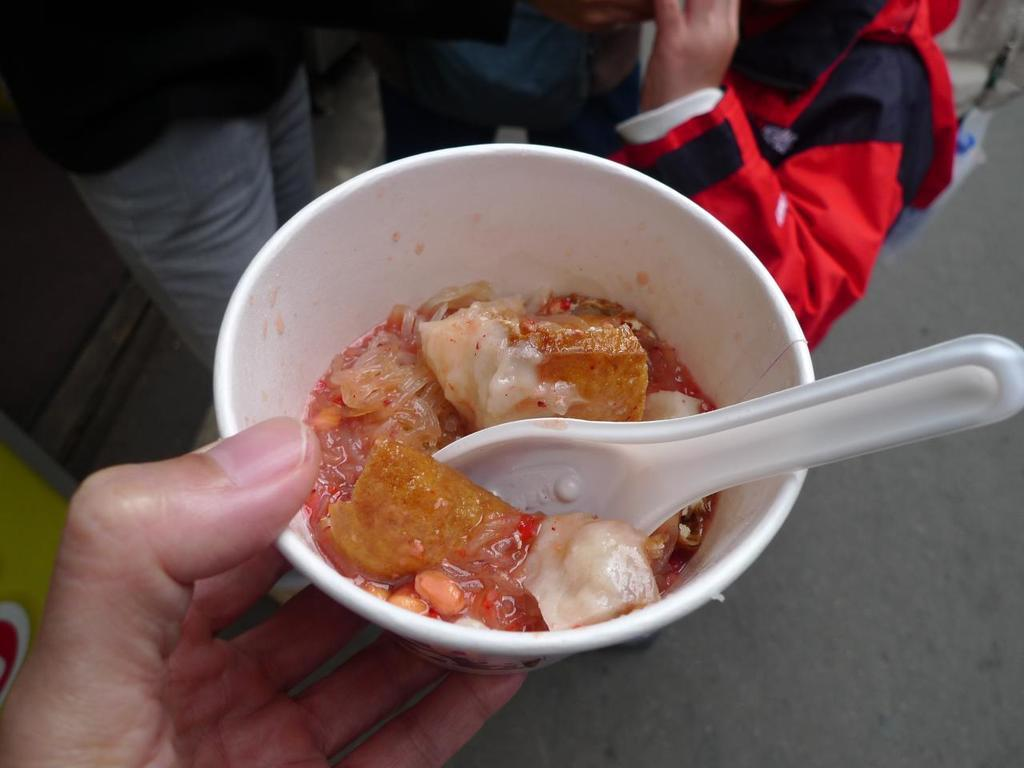What is the person in the image holding? The person is holding a bowl in the image. What is in the bowl that the person is holding? The bowl contains food in brown and cream colors. Can you describe the people in the background of the image? There are people standing in the background of the image. What type of van can be seen parked next to the person holding the bowl in the image? There is no van present in the image; it only features a person holding a bowl and people standing in the background. What type of mint is being used as a garnish on the food in the bowl? There is no mint visible in the image, and the food in the bowl is not described as having any garnish. 